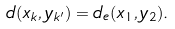Convert formula to latex. <formula><loc_0><loc_0><loc_500><loc_500>d ( x _ { k } , y _ { k ^ { \prime } } ) = d _ { e } ( x _ { 1 } , y _ { 2 } ) .</formula> 